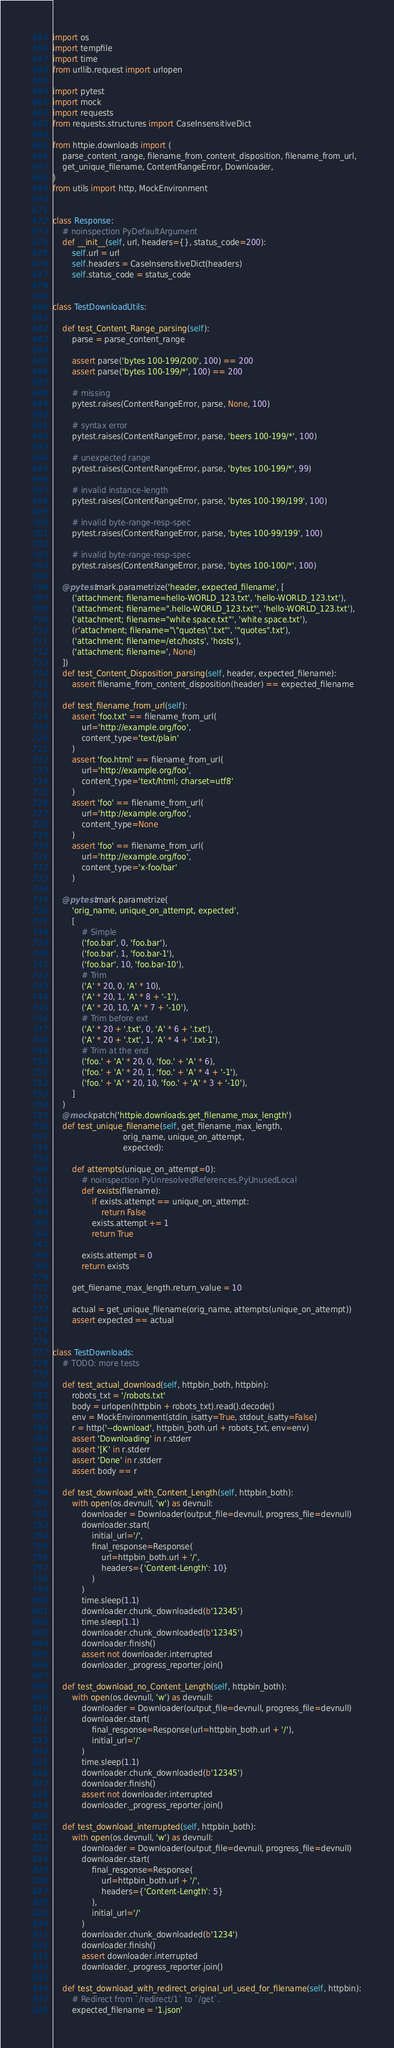<code> <loc_0><loc_0><loc_500><loc_500><_Python_>import os
import tempfile
import time
from urllib.request import urlopen

import pytest
import mock
import requests
from requests.structures import CaseInsensitiveDict

from httpie.downloads import (
    parse_content_range, filename_from_content_disposition, filename_from_url,
    get_unique_filename, ContentRangeError, Downloader,
)
from utils import http, MockEnvironment


class Response:
    # noinspection PyDefaultArgument
    def __init__(self, url, headers={}, status_code=200):
        self.url = url
        self.headers = CaseInsensitiveDict(headers)
        self.status_code = status_code


class TestDownloadUtils:

    def test_Content_Range_parsing(self):
        parse = parse_content_range

        assert parse('bytes 100-199/200', 100) == 200
        assert parse('bytes 100-199/*', 100) == 200

        # missing
        pytest.raises(ContentRangeError, parse, None, 100)

        # syntax error
        pytest.raises(ContentRangeError, parse, 'beers 100-199/*', 100)

        # unexpected range
        pytest.raises(ContentRangeError, parse, 'bytes 100-199/*', 99)

        # invalid instance-length
        pytest.raises(ContentRangeError, parse, 'bytes 100-199/199', 100)

        # invalid byte-range-resp-spec
        pytest.raises(ContentRangeError, parse, 'bytes 100-99/199', 100)

        # invalid byte-range-resp-spec
        pytest.raises(ContentRangeError, parse, 'bytes 100-100/*', 100)

    @pytest.mark.parametrize('header, expected_filename', [
        ('attachment; filename=hello-WORLD_123.txt', 'hello-WORLD_123.txt'),
        ('attachment; filename=".hello-WORLD_123.txt"', 'hello-WORLD_123.txt'),
        ('attachment; filename="white space.txt"', 'white space.txt'),
        (r'attachment; filename="\"quotes\".txt"', '"quotes".txt'),
        ('attachment; filename=/etc/hosts', 'hosts'),
        ('attachment; filename=', None)
    ])
    def test_Content_Disposition_parsing(self, header, expected_filename):
        assert filename_from_content_disposition(header) == expected_filename

    def test_filename_from_url(self):
        assert 'foo.txt' == filename_from_url(
            url='http://example.org/foo',
            content_type='text/plain'
        )
        assert 'foo.html' == filename_from_url(
            url='http://example.org/foo',
            content_type='text/html; charset=utf8'
        )
        assert 'foo' == filename_from_url(
            url='http://example.org/foo',
            content_type=None
        )
        assert 'foo' == filename_from_url(
            url='http://example.org/foo',
            content_type='x-foo/bar'
        )

    @pytest.mark.parametrize(
        'orig_name, unique_on_attempt, expected',
        [
            # Simple
            ('foo.bar', 0, 'foo.bar'),
            ('foo.bar', 1, 'foo.bar-1'),
            ('foo.bar', 10, 'foo.bar-10'),
            # Trim
            ('A' * 20, 0, 'A' * 10),
            ('A' * 20, 1, 'A' * 8 + '-1'),
            ('A' * 20, 10, 'A' * 7 + '-10'),
            # Trim before ext
            ('A' * 20 + '.txt', 0, 'A' * 6 + '.txt'),
            ('A' * 20 + '.txt', 1, 'A' * 4 + '.txt-1'),
            # Trim at the end
            ('foo.' + 'A' * 20, 0, 'foo.' + 'A' * 6),
            ('foo.' + 'A' * 20, 1, 'foo.' + 'A' * 4 + '-1'),
            ('foo.' + 'A' * 20, 10, 'foo.' + 'A' * 3 + '-10'),
        ]
    )
    @mock.patch('httpie.downloads.get_filename_max_length')
    def test_unique_filename(self, get_filename_max_length,
                             orig_name, unique_on_attempt,
                             expected):

        def attempts(unique_on_attempt=0):
            # noinspection PyUnresolvedReferences,PyUnusedLocal
            def exists(filename):
                if exists.attempt == unique_on_attempt:
                    return False
                exists.attempt += 1
                return True

            exists.attempt = 0
            return exists

        get_filename_max_length.return_value = 10

        actual = get_unique_filename(orig_name, attempts(unique_on_attempt))
        assert expected == actual


class TestDownloads:
    # TODO: more tests

    def test_actual_download(self, httpbin_both, httpbin):
        robots_txt = '/robots.txt'
        body = urlopen(httpbin + robots_txt).read().decode()
        env = MockEnvironment(stdin_isatty=True, stdout_isatty=False)
        r = http('--download', httpbin_both.url + robots_txt, env=env)
        assert 'Downloading' in r.stderr
        assert '[K' in r.stderr
        assert 'Done' in r.stderr
        assert body == r

    def test_download_with_Content_Length(self, httpbin_both):
        with open(os.devnull, 'w') as devnull:
            downloader = Downloader(output_file=devnull, progress_file=devnull)
            downloader.start(
                initial_url='/',
                final_response=Response(
                    url=httpbin_both.url + '/',
                    headers={'Content-Length': 10}
                )
            )
            time.sleep(1.1)
            downloader.chunk_downloaded(b'12345')
            time.sleep(1.1)
            downloader.chunk_downloaded(b'12345')
            downloader.finish()
            assert not downloader.interrupted
            downloader._progress_reporter.join()

    def test_download_no_Content_Length(self, httpbin_both):
        with open(os.devnull, 'w') as devnull:
            downloader = Downloader(output_file=devnull, progress_file=devnull)
            downloader.start(
                final_response=Response(url=httpbin_both.url + '/'),
                initial_url='/'
            )
            time.sleep(1.1)
            downloader.chunk_downloaded(b'12345')
            downloader.finish()
            assert not downloader.interrupted
            downloader._progress_reporter.join()

    def test_download_interrupted(self, httpbin_both):
        with open(os.devnull, 'w') as devnull:
            downloader = Downloader(output_file=devnull, progress_file=devnull)
            downloader.start(
                final_response=Response(
                    url=httpbin_both.url + '/',
                    headers={'Content-Length': 5}
                ),
                initial_url='/'
            )
            downloader.chunk_downloaded(b'1234')
            downloader.finish()
            assert downloader.interrupted
            downloader._progress_reporter.join()

    def test_download_with_redirect_original_url_used_for_filename(self, httpbin):
        # Redirect from `/redirect/1` to `/get`.
        expected_filename = '1.json'</code> 